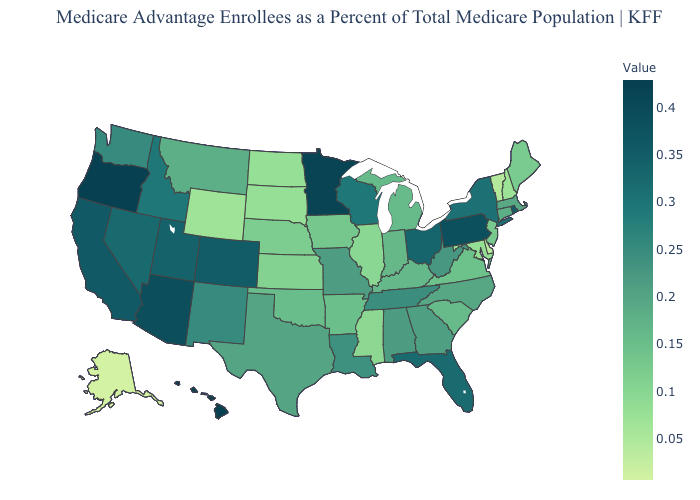Which states have the lowest value in the USA?
Give a very brief answer. Alaska. Does Oregon have the highest value in the West?
Answer briefly. No. Which states have the lowest value in the USA?
Be succinct. Alaska. Does Florida have the highest value in the South?
Give a very brief answer. Yes. Among the states that border North Dakota , which have the lowest value?
Be succinct. South Dakota. Among the states that border Virginia , which have the highest value?
Be succinct. Tennessee. 